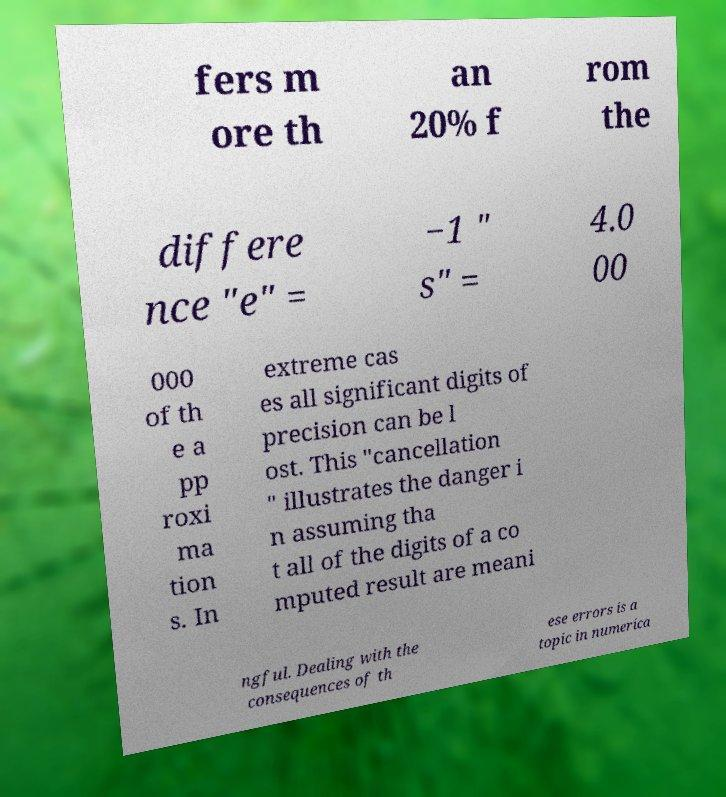I need the written content from this picture converted into text. Can you do that? fers m ore th an 20% f rom the differe nce "e" = −1 " s" = 4.0 00 000 of th e a pp roxi ma tion s. In extreme cas es all significant digits of precision can be l ost. This "cancellation " illustrates the danger i n assuming tha t all of the digits of a co mputed result are meani ngful. Dealing with the consequences of th ese errors is a topic in numerica 